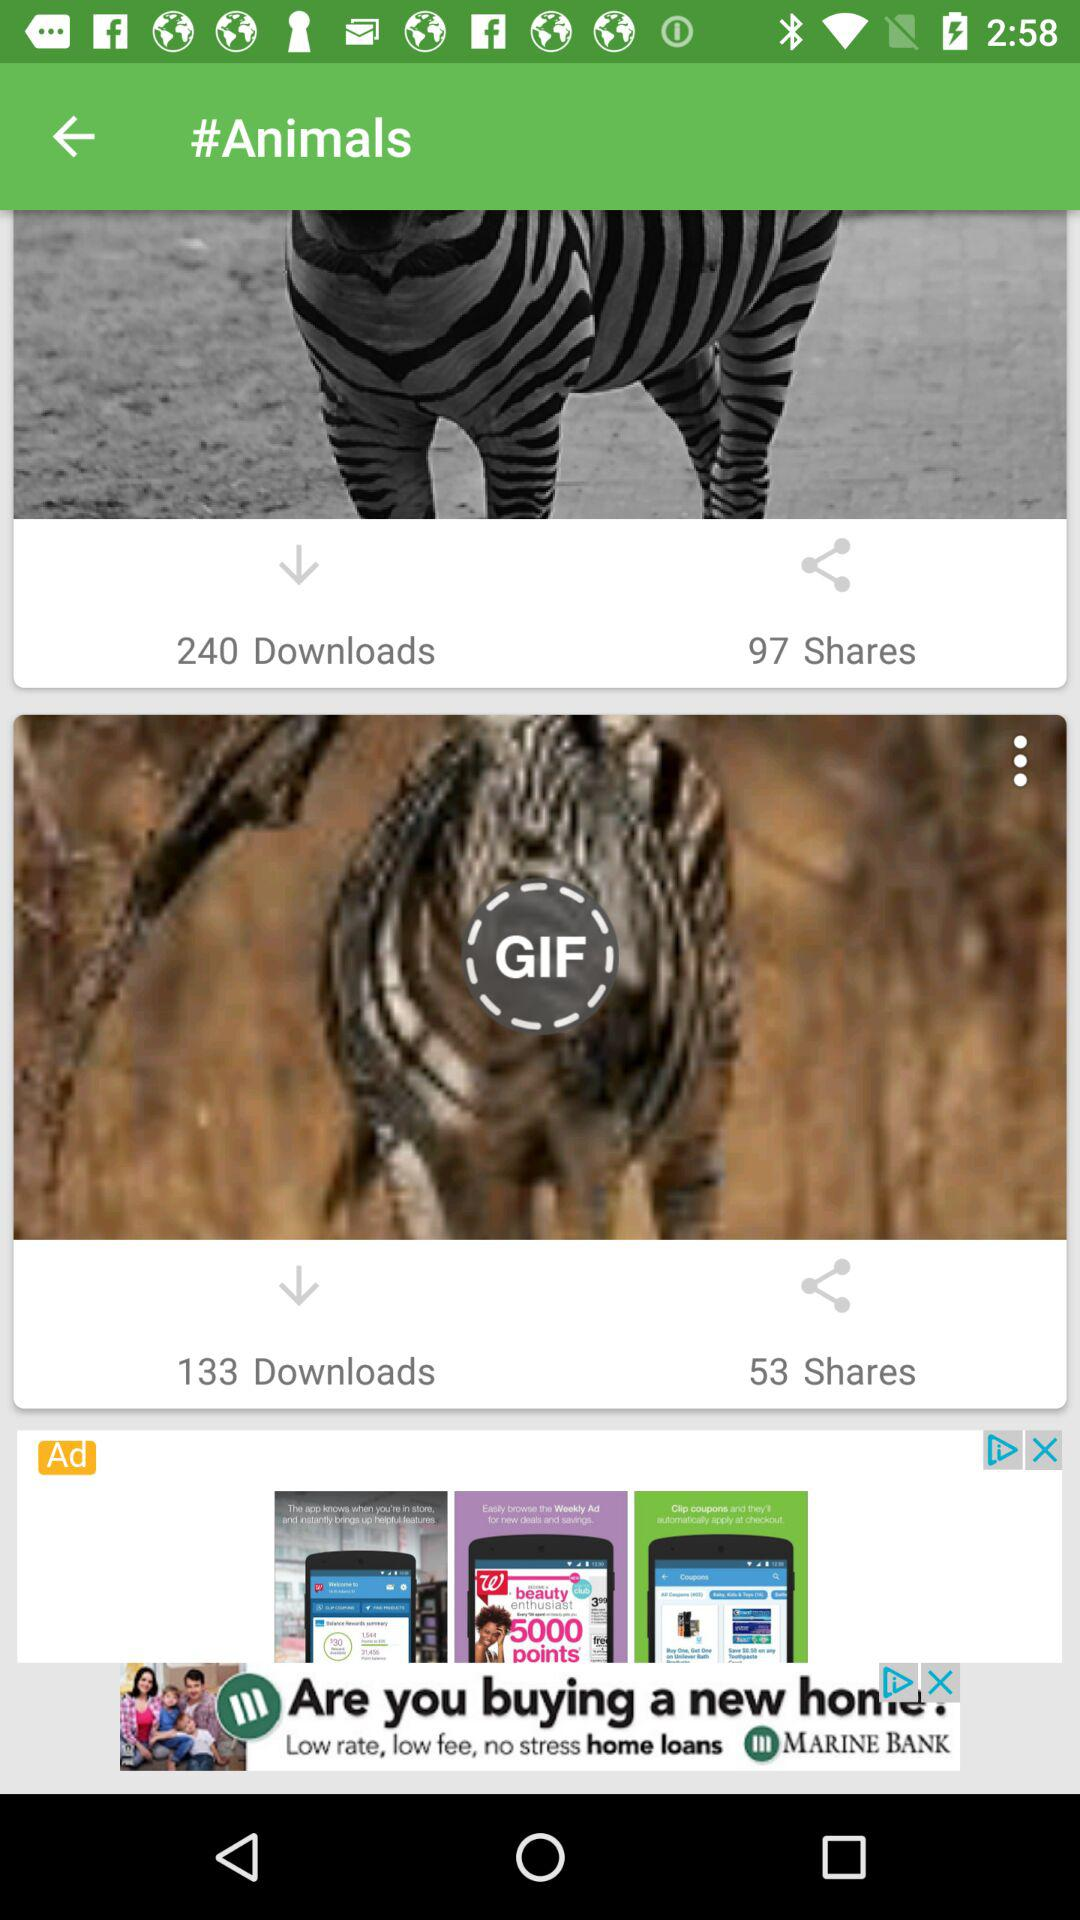How many GIFs have been downloaded? The downloaded GIFs are 133. 